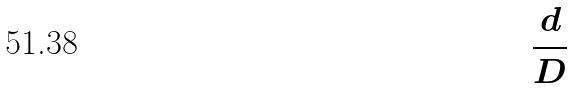<formula> <loc_0><loc_0><loc_500><loc_500>\frac { d } { D }</formula> 